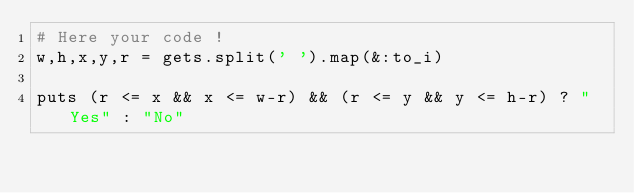Convert code to text. <code><loc_0><loc_0><loc_500><loc_500><_Ruby_># Here your code !
w,h,x,y,r = gets.split(' ').map(&:to_i)

puts (r <= x && x <= w-r) && (r <= y && y <= h-r) ? "Yes" : "No"</code> 